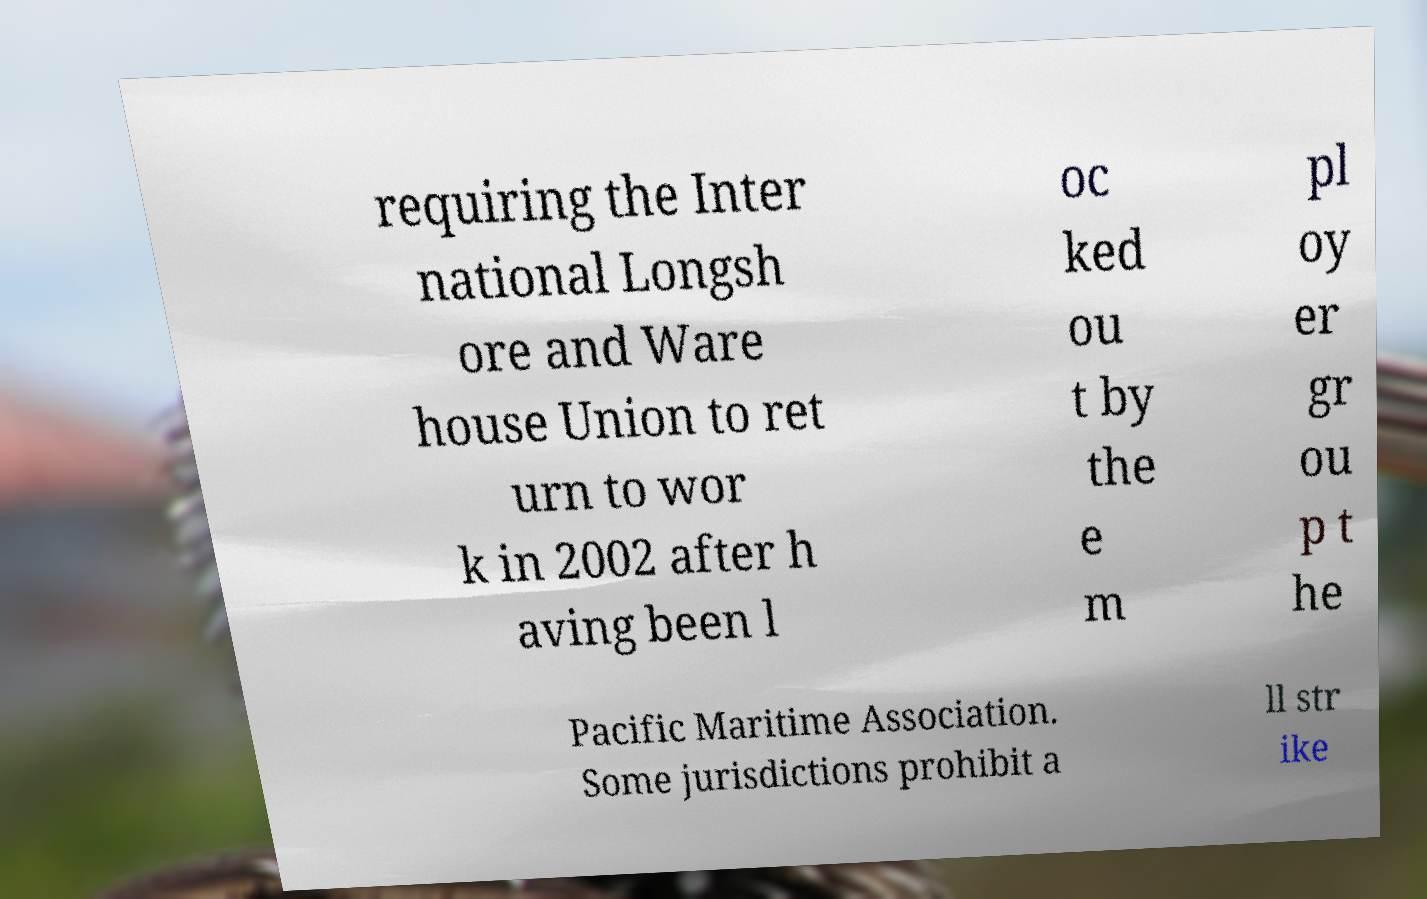What messages or text are displayed in this image? I need them in a readable, typed format. requiring the Inter national Longsh ore and Ware house Union to ret urn to wor k in 2002 after h aving been l oc ked ou t by the e m pl oy er gr ou p t he Pacific Maritime Association. Some jurisdictions prohibit a ll str ike 